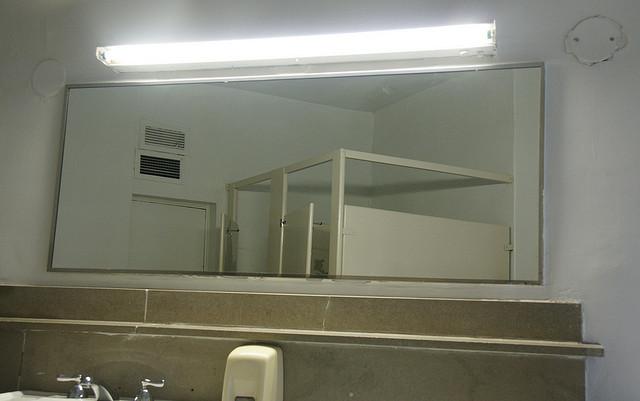Is the light on?
Answer briefly. Yes. Are there two mirrors?
Write a very short answer. No. Where is the light?
Give a very brief answer. Above mirror. What bathroom features are reflected in the mirror?
Answer briefly. Stalls. Why does the bathroom need two vents?
Quick response, please. For air and heat. Was something hanging in the top right corner?
Give a very brief answer. Yes. 